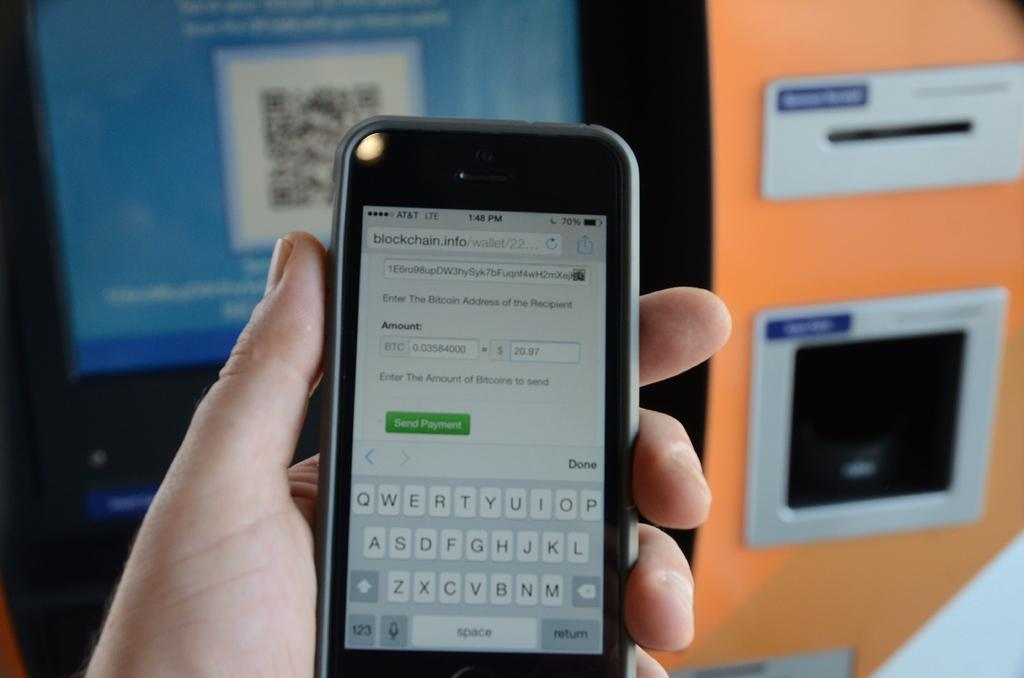<image>
Relay a brief, clear account of the picture shown. An iphone displaying a blockchain website on it 